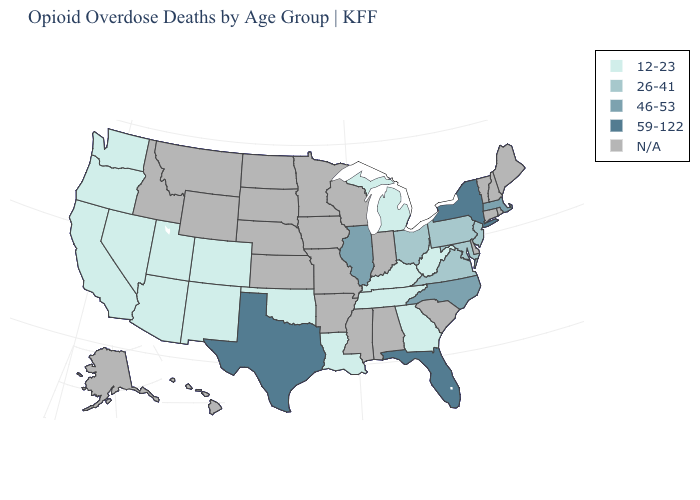What is the value of Alaska?
Quick response, please. N/A. Name the states that have a value in the range 46-53?
Short answer required. Illinois, Massachusetts, North Carolina. What is the value of Florida?
Concise answer only. 59-122. Name the states that have a value in the range 59-122?
Give a very brief answer. Florida, New York, Texas. What is the lowest value in the South?
Give a very brief answer. 12-23. Name the states that have a value in the range 12-23?
Keep it brief. Arizona, California, Colorado, Georgia, Kentucky, Louisiana, Michigan, Nevada, New Mexico, Oklahoma, Oregon, Tennessee, Utah, Washington, West Virginia. What is the highest value in the MidWest ?
Concise answer only. 46-53. What is the lowest value in states that border Kansas?
Be succinct. 12-23. What is the value of Ohio?
Quick response, please. 26-41. Among the states that border Illinois , which have the lowest value?
Keep it brief. Kentucky. What is the highest value in states that border Michigan?
Be succinct. 26-41. Name the states that have a value in the range 59-122?
Keep it brief. Florida, New York, Texas. Name the states that have a value in the range 46-53?
Concise answer only. Illinois, Massachusetts, North Carolina. What is the value of New Jersey?
Answer briefly. 26-41. 